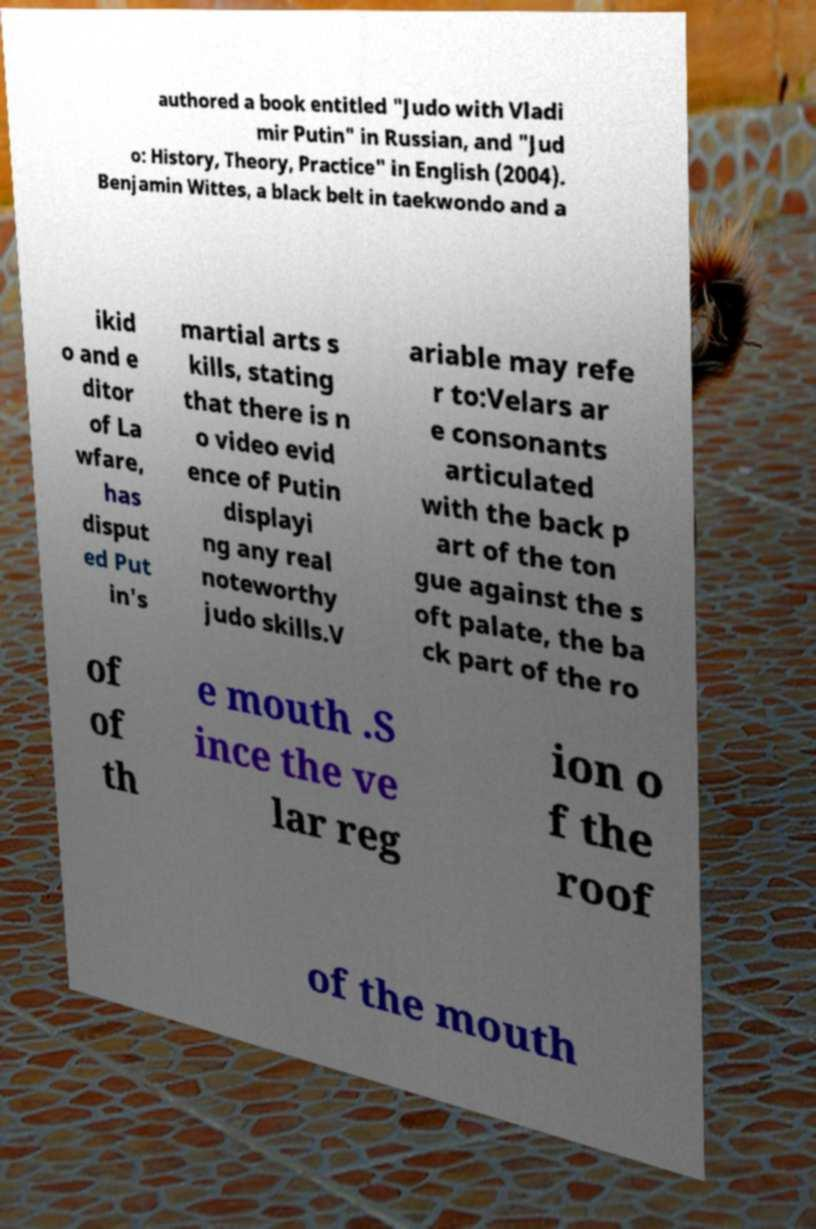Can you read and provide the text displayed in the image?This photo seems to have some interesting text. Can you extract and type it out for me? authored a book entitled "Judo with Vladi mir Putin" in Russian, and "Jud o: History, Theory, Practice" in English (2004). Benjamin Wittes, a black belt in taekwondo and a ikid o and e ditor of La wfare, has disput ed Put in's martial arts s kills, stating that there is n o video evid ence of Putin displayi ng any real noteworthy judo skills.V ariable may refe r to:Velars ar e consonants articulated with the back p art of the ton gue against the s oft palate, the ba ck part of the ro of of th e mouth .S ince the ve lar reg ion o f the roof of the mouth 